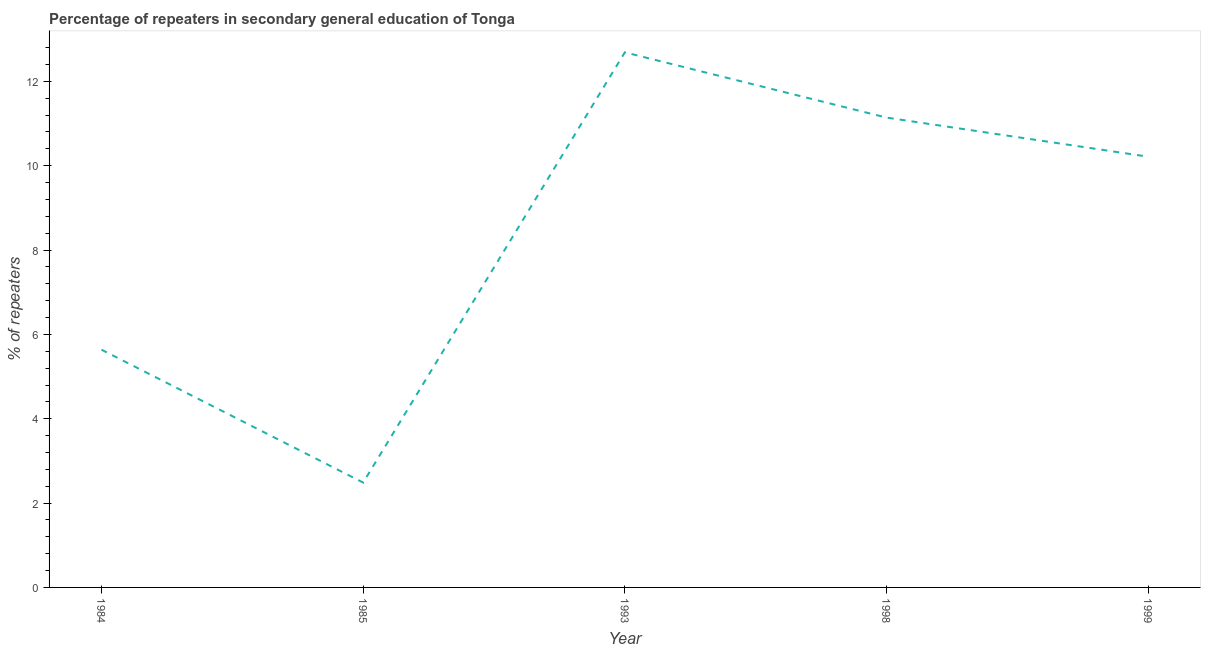What is the percentage of repeaters in 1985?
Keep it short and to the point. 2.49. Across all years, what is the maximum percentage of repeaters?
Your answer should be compact. 12.69. Across all years, what is the minimum percentage of repeaters?
Give a very brief answer. 2.49. What is the sum of the percentage of repeaters?
Give a very brief answer. 42.17. What is the difference between the percentage of repeaters in 1984 and 1993?
Offer a terse response. -7.05. What is the average percentage of repeaters per year?
Keep it short and to the point. 8.43. What is the median percentage of repeaters?
Make the answer very short. 10.21. Do a majority of the years between 1999 and 1984 (inclusive) have percentage of repeaters greater than 5.2 %?
Your response must be concise. Yes. What is the ratio of the percentage of repeaters in 1985 to that in 1993?
Give a very brief answer. 0.2. Is the percentage of repeaters in 1984 less than that in 1993?
Provide a succinct answer. Yes. Is the difference between the percentage of repeaters in 1998 and 1999 greater than the difference between any two years?
Your answer should be very brief. No. What is the difference between the highest and the second highest percentage of repeaters?
Provide a succinct answer. 1.55. What is the difference between the highest and the lowest percentage of repeaters?
Your answer should be compact. 10.2. Does the percentage of repeaters monotonically increase over the years?
Give a very brief answer. No. How many years are there in the graph?
Provide a succinct answer. 5. Does the graph contain any zero values?
Your response must be concise. No. What is the title of the graph?
Offer a terse response. Percentage of repeaters in secondary general education of Tonga. What is the label or title of the X-axis?
Provide a succinct answer. Year. What is the label or title of the Y-axis?
Your response must be concise. % of repeaters. What is the % of repeaters of 1984?
Ensure brevity in your answer.  5.64. What is the % of repeaters of 1985?
Make the answer very short. 2.49. What is the % of repeaters of 1993?
Offer a terse response. 12.69. What is the % of repeaters in 1998?
Provide a short and direct response. 11.14. What is the % of repeaters of 1999?
Ensure brevity in your answer.  10.21. What is the difference between the % of repeaters in 1984 and 1985?
Your response must be concise. 3.15. What is the difference between the % of repeaters in 1984 and 1993?
Your response must be concise. -7.05. What is the difference between the % of repeaters in 1984 and 1998?
Make the answer very short. -5.5. What is the difference between the % of repeaters in 1984 and 1999?
Give a very brief answer. -4.58. What is the difference between the % of repeaters in 1985 and 1993?
Offer a terse response. -10.2. What is the difference between the % of repeaters in 1985 and 1998?
Offer a terse response. -8.66. What is the difference between the % of repeaters in 1985 and 1999?
Make the answer very short. -7.73. What is the difference between the % of repeaters in 1993 and 1998?
Offer a terse response. 1.55. What is the difference between the % of repeaters in 1993 and 1999?
Ensure brevity in your answer.  2.47. What is the difference between the % of repeaters in 1998 and 1999?
Provide a short and direct response. 0.93. What is the ratio of the % of repeaters in 1984 to that in 1985?
Offer a very short reply. 2.27. What is the ratio of the % of repeaters in 1984 to that in 1993?
Provide a short and direct response. 0.44. What is the ratio of the % of repeaters in 1984 to that in 1998?
Your response must be concise. 0.51. What is the ratio of the % of repeaters in 1984 to that in 1999?
Your answer should be very brief. 0.55. What is the ratio of the % of repeaters in 1985 to that in 1993?
Offer a very short reply. 0.2. What is the ratio of the % of repeaters in 1985 to that in 1998?
Your answer should be compact. 0.22. What is the ratio of the % of repeaters in 1985 to that in 1999?
Offer a terse response. 0.24. What is the ratio of the % of repeaters in 1993 to that in 1998?
Your answer should be compact. 1.14. What is the ratio of the % of repeaters in 1993 to that in 1999?
Your answer should be compact. 1.24. What is the ratio of the % of repeaters in 1998 to that in 1999?
Offer a very short reply. 1.09. 